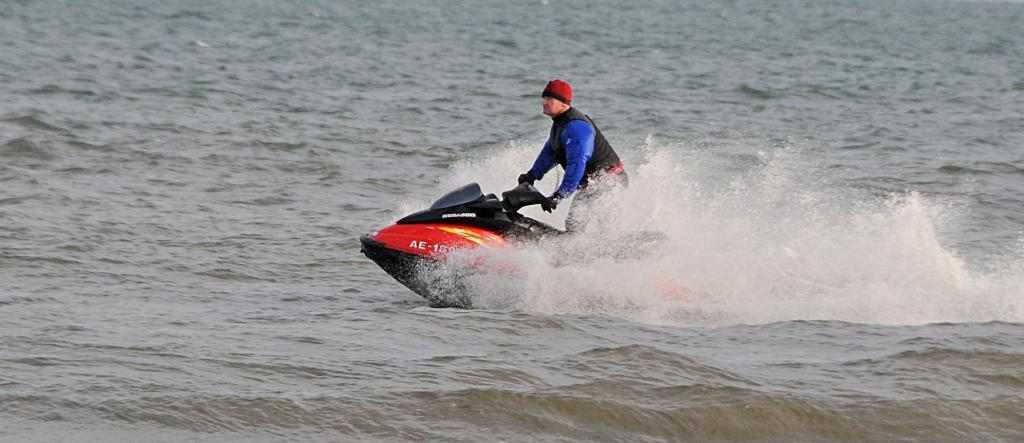What is the main subject of the image? There is a person in the image. What is the person doing in the image? The person is surfing on water. How many sticks are being used by the person while surfing in the image? There are no sticks visible in the image; the person is surfing on water using a surfboard. What type of insect can be seen crawling on the person's bed in the image? There is no bed or insect present in the image; it features a person surfing on water. 